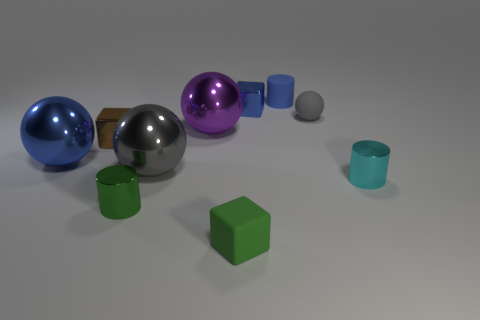There is a small cube behind the tiny gray sphere; does it have the same color as the small matte cylinder?
Provide a short and direct response. Yes. There is another small thing that is the same shape as the purple thing; what is its material?
Keep it short and to the point. Rubber. What number of matte cylinders are the same size as the green rubber block?
Provide a short and direct response. 1. What is the green cube made of?
Give a very brief answer. Rubber. Are there more cyan objects than big spheres?
Ensure brevity in your answer.  No. Is the shape of the tiny green shiny thing the same as the cyan thing?
Keep it short and to the point. Yes. Does the big ball left of the large gray metal sphere have the same color as the tiny cube behind the brown shiny object?
Your response must be concise. Yes. Is the number of gray things in front of the small green matte block less than the number of balls that are in front of the large blue metal sphere?
Your answer should be compact. Yes. The tiny green object behind the tiny green matte object has what shape?
Provide a succinct answer. Cylinder. How many other things are made of the same material as the blue cylinder?
Give a very brief answer. 2. 